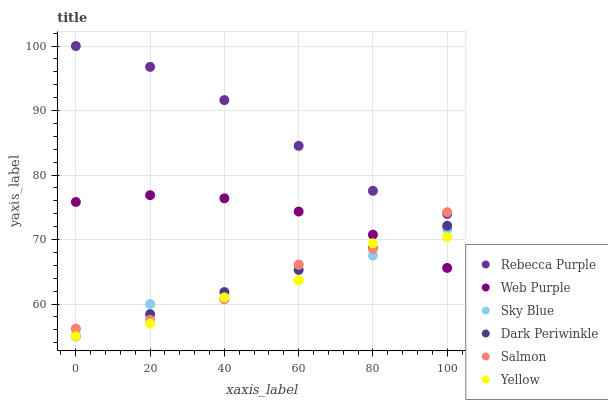Does Yellow have the minimum area under the curve?
Answer yes or no. Yes. Does Rebecca Purple have the maximum area under the curve?
Answer yes or no. Yes. Does Web Purple have the minimum area under the curve?
Answer yes or no. No. Does Web Purple have the maximum area under the curve?
Answer yes or no. No. Is Dark Periwinkle the smoothest?
Answer yes or no. Yes. Is Sky Blue the roughest?
Answer yes or no. Yes. Is Yellow the smoothest?
Answer yes or no. No. Is Yellow the roughest?
Answer yes or no. No. Does Yellow have the lowest value?
Answer yes or no. Yes. Does Web Purple have the lowest value?
Answer yes or no. No. Does Rebecca Purple have the highest value?
Answer yes or no. Yes. Does Web Purple have the highest value?
Answer yes or no. No. Is Yellow less than Rebecca Purple?
Answer yes or no. Yes. Is Rebecca Purple greater than Web Purple?
Answer yes or no. Yes. Does Web Purple intersect Sky Blue?
Answer yes or no. Yes. Is Web Purple less than Sky Blue?
Answer yes or no. No. Is Web Purple greater than Sky Blue?
Answer yes or no. No. Does Yellow intersect Rebecca Purple?
Answer yes or no. No. 